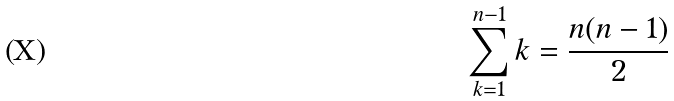<formula> <loc_0><loc_0><loc_500><loc_500>\sum _ { k = 1 } ^ { n - 1 } k = \frac { n ( n - 1 ) } { 2 }</formula> 